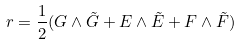<formula> <loc_0><loc_0><loc_500><loc_500>r = { \frac { 1 } { 2 } } ( G \wedge \tilde { G } + E \wedge \tilde { E } + F \wedge \tilde { F } )</formula> 